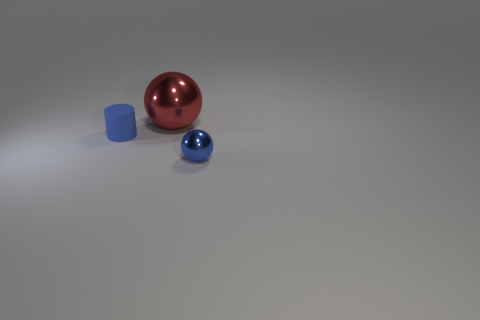Are there any other things that are the same size as the red metal ball?
Make the answer very short. No. There is another tiny thing that is the same shape as the red object; what is it made of?
Keep it short and to the point. Metal. How many blue matte objects are the same size as the blue metal object?
Keep it short and to the point. 1. What is the shape of the blue metal thing?
Keep it short and to the point. Sphere. What size is the thing that is right of the tiny blue cylinder and to the left of the small metal thing?
Ensure brevity in your answer.  Large. What is the material of the ball in front of the rubber object?
Offer a very short reply. Metal. Is the color of the cylinder the same as the sphere that is on the right side of the red ball?
Make the answer very short. Yes. How many things are metal spheres that are in front of the blue cylinder or things that are to the left of the large metallic thing?
Your response must be concise. 2. What is the color of the object that is on the left side of the blue sphere and on the right side of the blue matte object?
Give a very brief answer. Red. Is the number of blue shiny blocks greater than the number of red things?
Provide a succinct answer. No. 